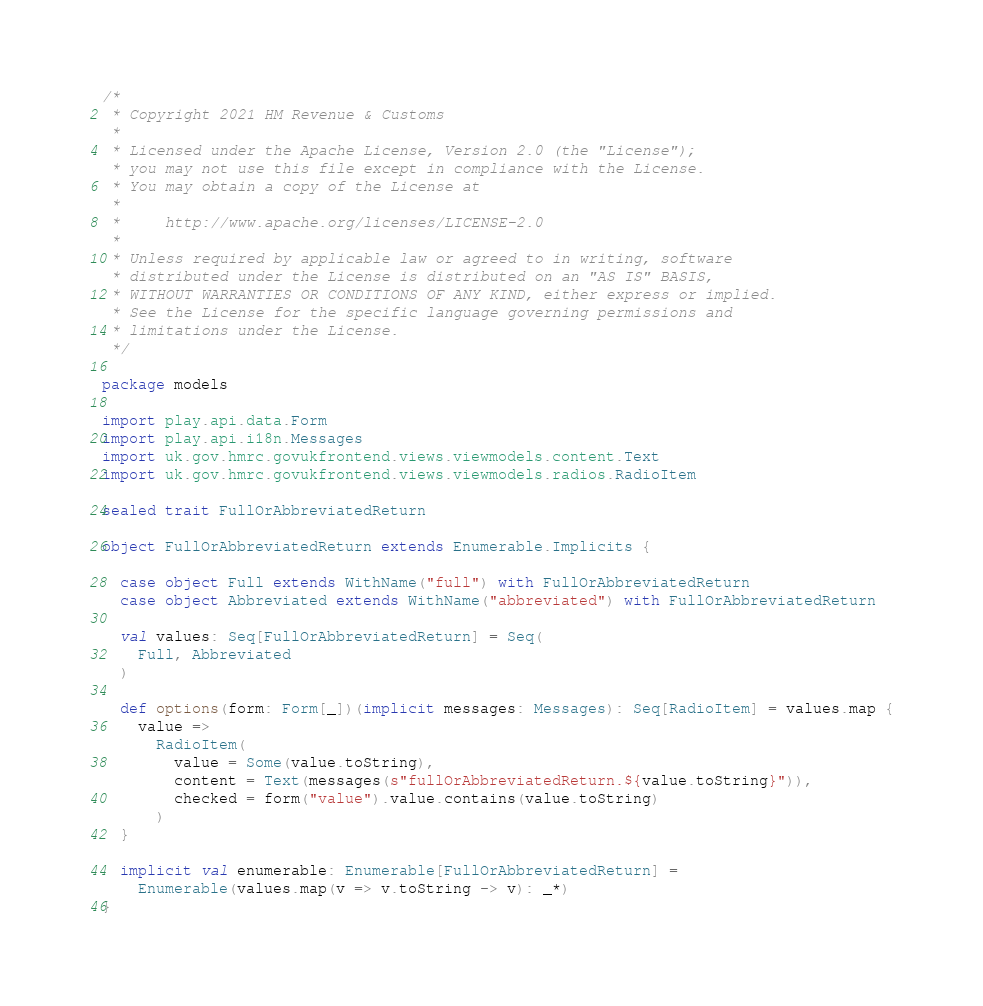<code> <loc_0><loc_0><loc_500><loc_500><_Scala_>/*
 * Copyright 2021 HM Revenue & Customs
 *
 * Licensed under the Apache License, Version 2.0 (the "License");
 * you may not use this file except in compliance with the License.
 * You may obtain a copy of the License at
 *
 *     http://www.apache.org/licenses/LICENSE-2.0
 *
 * Unless required by applicable law or agreed to in writing, software
 * distributed under the License is distributed on an "AS IS" BASIS,
 * WITHOUT WARRANTIES OR CONDITIONS OF ANY KIND, either express or implied.
 * See the License for the specific language governing permissions and
 * limitations under the License.
 */

package models

import play.api.data.Form
import play.api.i18n.Messages
import uk.gov.hmrc.govukfrontend.views.viewmodels.content.Text
import uk.gov.hmrc.govukfrontend.views.viewmodels.radios.RadioItem

sealed trait FullOrAbbreviatedReturn

object FullOrAbbreviatedReturn extends Enumerable.Implicits {

  case object Full extends WithName("full") with FullOrAbbreviatedReturn
  case object Abbreviated extends WithName("abbreviated") with FullOrAbbreviatedReturn

  val values: Seq[FullOrAbbreviatedReturn] = Seq(
    Full, Abbreviated
  )

  def options(form: Form[_])(implicit messages: Messages): Seq[RadioItem] = values.map {
    value =>
      RadioItem(
        value = Some(value.toString),
        content = Text(messages(s"fullOrAbbreviatedReturn.${value.toString}")),
        checked = form("value").value.contains(value.toString)
      )
  }

  implicit val enumerable: Enumerable[FullOrAbbreviatedReturn] =
    Enumerable(values.map(v => v.toString -> v): _*)
}
</code> 